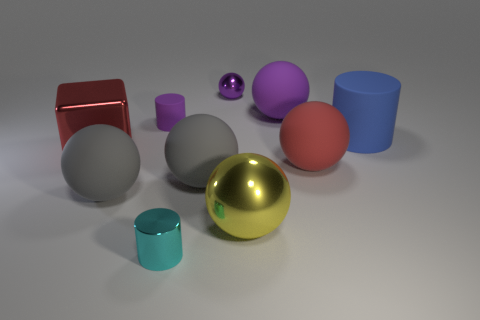There is a tiny rubber thing that is the same color as the small metallic sphere; what is its shape?
Ensure brevity in your answer.  Cylinder. Does the metal cylinder have the same size as the purple shiny thing?
Your response must be concise. Yes. Is the number of rubber spheres that are left of the red matte sphere greater than the number of large rubber blocks?
Your answer should be compact. Yes. What is the size of the block that is made of the same material as the yellow object?
Provide a short and direct response. Large. There is a large metallic ball; are there any cyan cylinders left of it?
Your answer should be compact. Yes. Do the large yellow thing and the big red rubber object have the same shape?
Make the answer very short. Yes. There is a rubber cylinder on the right side of the purple rubber object on the right side of the metallic sphere that is in front of the red shiny object; what size is it?
Your answer should be compact. Large. What is the big red ball made of?
Your answer should be very brief. Rubber. There is another rubber ball that is the same color as the tiny sphere; what size is it?
Make the answer very short. Large. There is a tiny purple metal thing; is it the same shape as the big rubber object that is behind the large matte cylinder?
Your answer should be very brief. Yes. 